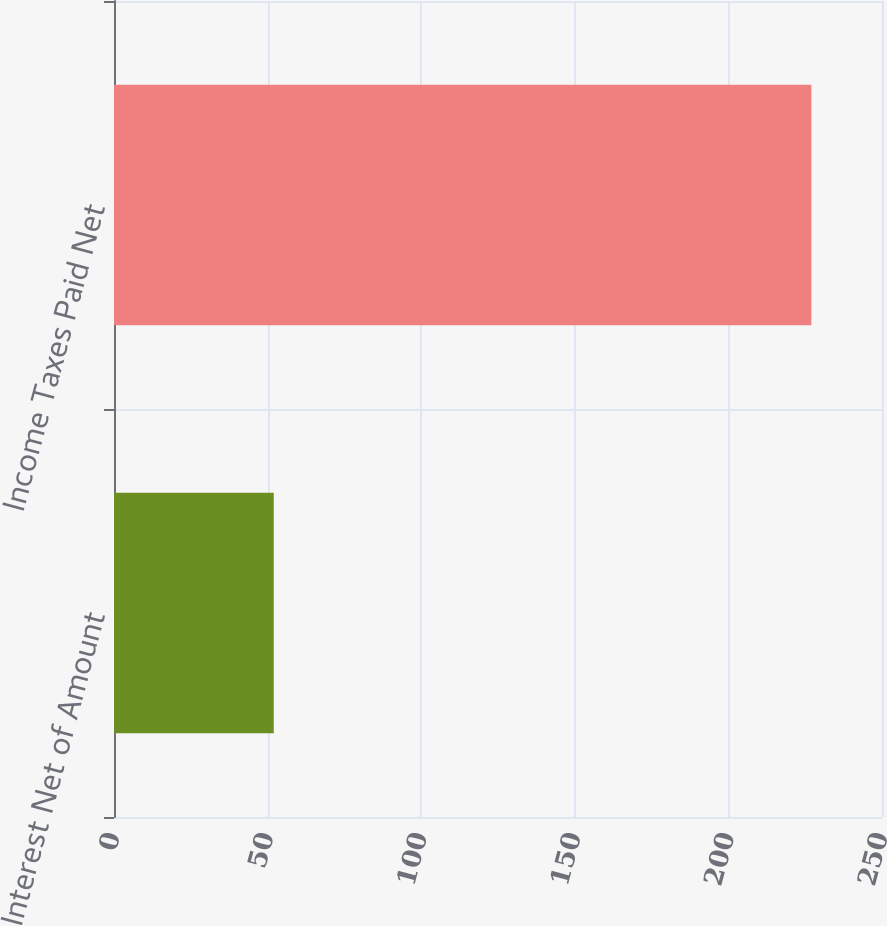Convert chart to OTSL. <chart><loc_0><loc_0><loc_500><loc_500><bar_chart><fcel>Interest Net of Amount<fcel>Income Taxes Paid Net<nl><fcel>52<fcel>227<nl></chart> 